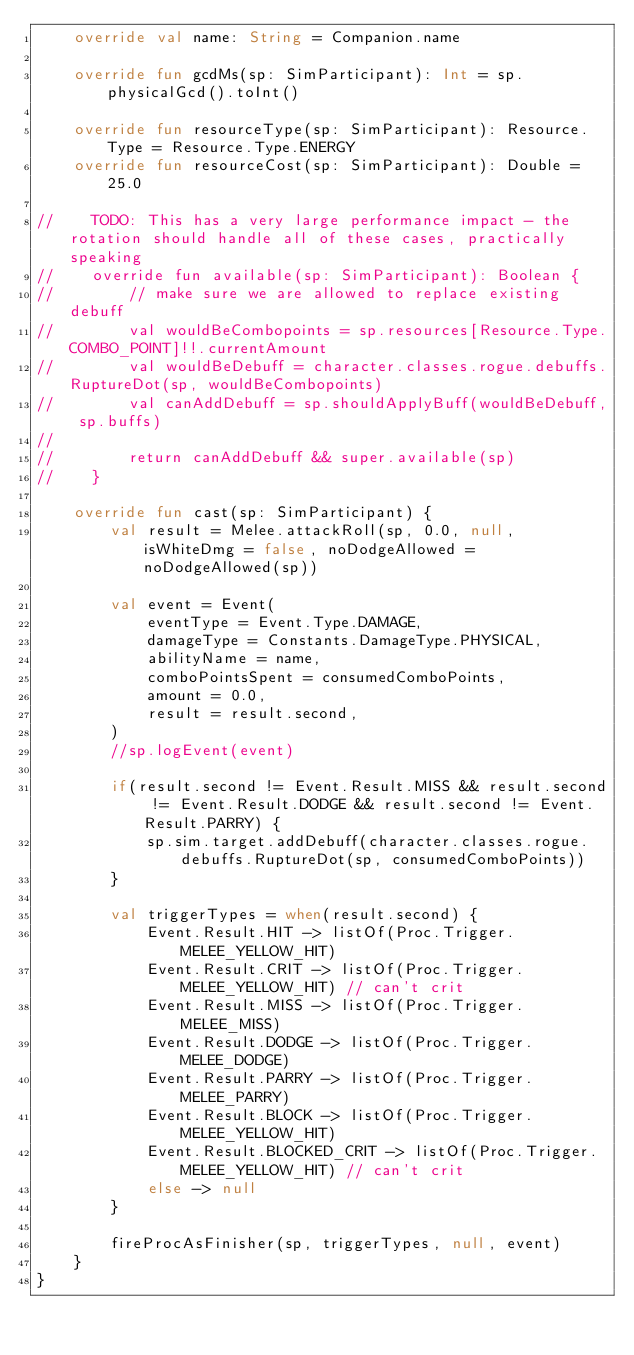Convert code to text. <code><loc_0><loc_0><loc_500><loc_500><_Kotlin_>    override val name: String = Companion.name

    override fun gcdMs(sp: SimParticipant): Int = sp.physicalGcd().toInt()

    override fun resourceType(sp: SimParticipant): Resource.Type = Resource.Type.ENERGY
    override fun resourceCost(sp: SimParticipant): Double = 25.0

//    TODO: This has a very large performance impact - the rotation should handle all of these cases, practically speaking
//    override fun available(sp: SimParticipant): Boolean {
//        // make sure we are allowed to replace existing debuff
//        val wouldBeCombopoints = sp.resources[Resource.Type.COMBO_POINT]!!.currentAmount
//        val wouldBeDebuff = character.classes.rogue.debuffs.RuptureDot(sp, wouldBeCombopoints)
//        val canAddDebuff = sp.shouldApplyBuff(wouldBeDebuff, sp.buffs)
//
//        return canAddDebuff && super.available(sp)
//    }

    override fun cast(sp: SimParticipant) {
        val result = Melee.attackRoll(sp, 0.0, null, isWhiteDmg = false, noDodgeAllowed = noDodgeAllowed(sp))

        val event = Event(
            eventType = Event.Type.DAMAGE,
            damageType = Constants.DamageType.PHYSICAL,
            abilityName = name,
            comboPointsSpent = consumedComboPoints,
            amount = 0.0,
            result = result.second,
        )
        //sp.logEvent(event)

        if(result.second != Event.Result.MISS && result.second != Event.Result.DODGE && result.second != Event.Result.PARRY) {
            sp.sim.target.addDebuff(character.classes.rogue.debuffs.RuptureDot(sp, consumedComboPoints))
        }

        val triggerTypes = when(result.second) {
            Event.Result.HIT -> listOf(Proc.Trigger.MELEE_YELLOW_HIT)
            Event.Result.CRIT -> listOf(Proc.Trigger.MELEE_YELLOW_HIT) // can't crit
            Event.Result.MISS -> listOf(Proc.Trigger.MELEE_MISS)
            Event.Result.DODGE -> listOf(Proc.Trigger.MELEE_DODGE)
            Event.Result.PARRY -> listOf(Proc.Trigger.MELEE_PARRY)
            Event.Result.BLOCK -> listOf(Proc.Trigger.MELEE_YELLOW_HIT)
            Event.Result.BLOCKED_CRIT -> listOf(Proc.Trigger.MELEE_YELLOW_HIT) // can't crit
            else -> null
        }

        fireProcAsFinisher(sp, triggerTypes, null, event)
    }
}
</code> 